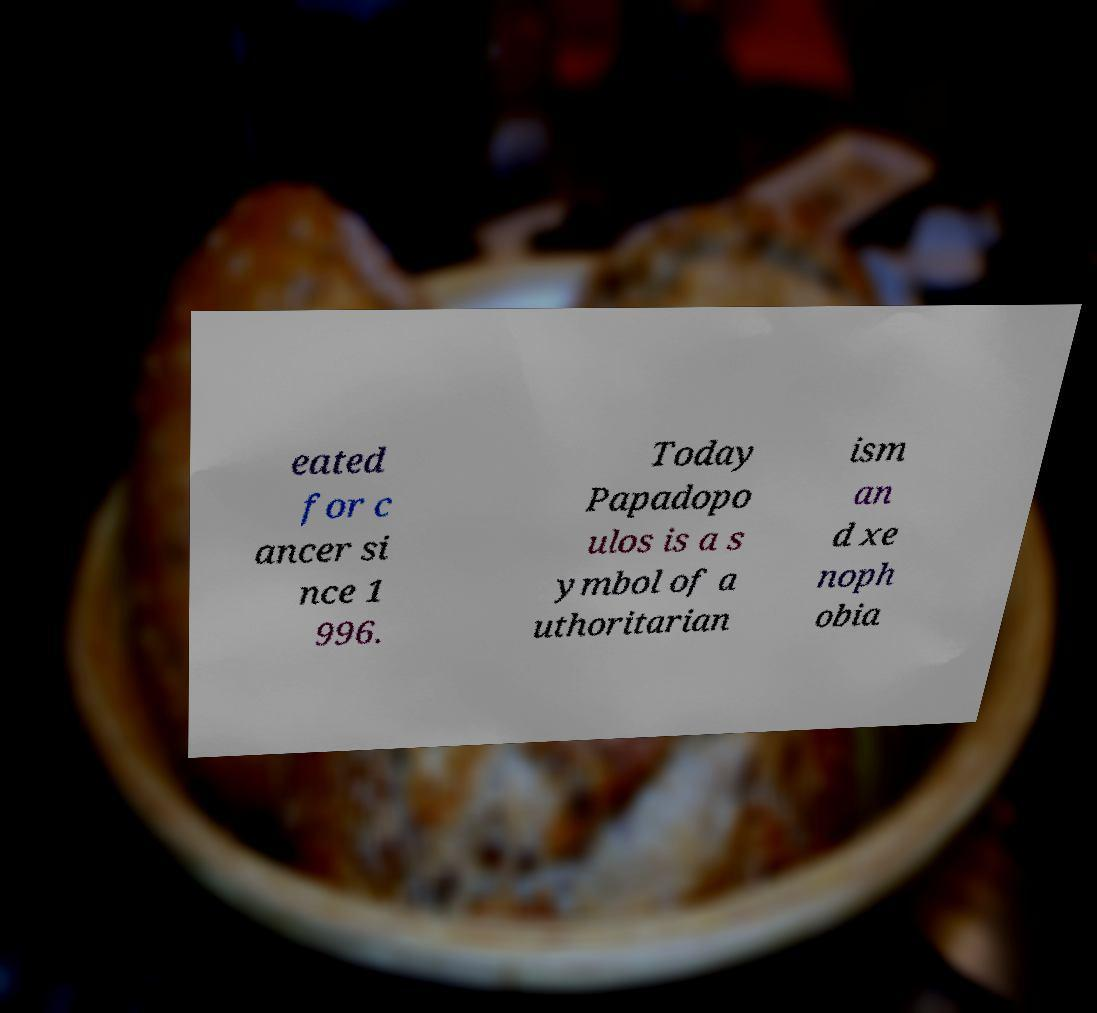Please identify and transcribe the text found in this image. eated for c ancer si nce 1 996. Today Papadopo ulos is a s ymbol of a uthoritarian ism an d xe noph obia 